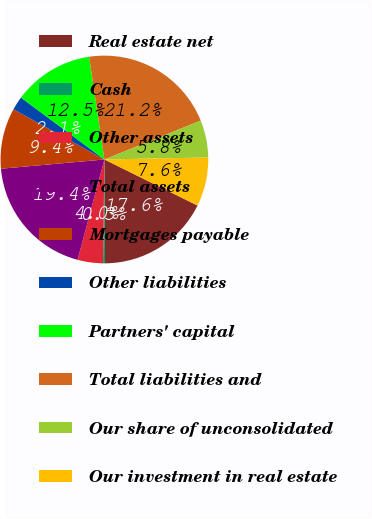Convert chart to OTSL. <chart><loc_0><loc_0><loc_500><loc_500><pie_chart><fcel>Real estate net<fcel>Cash<fcel>Other assets<fcel>Total assets<fcel>Mortgages payable<fcel>Other liabilities<fcel>Partners' capital<fcel>Total liabilities and<fcel>Our share of unconsolidated<fcel>Our investment in real estate<nl><fcel>17.59%<fcel>0.3%<fcel>3.96%<fcel>19.42%<fcel>9.45%<fcel>2.13%<fcel>12.49%<fcel>21.25%<fcel>5.79%<fcel>7.62%<nl></chart> 